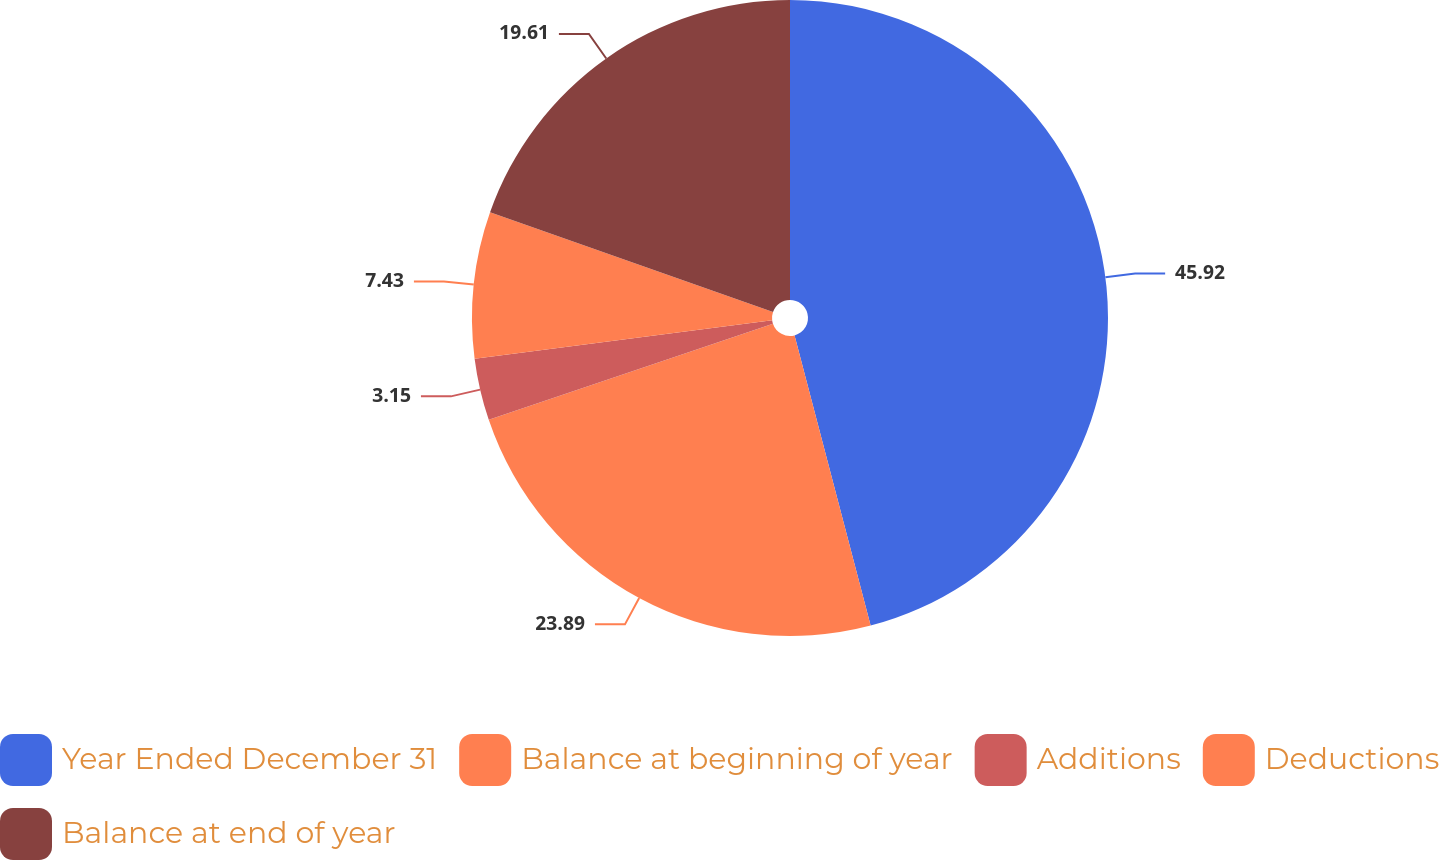Convert chart to OTSL. <chart><loc_0><loc_0><loc_500><loc_500><pie_chart><fcel>Year Ended December 31<fcel>Balance at beginning of year<fcel>Additions<fcel>Deductions<fcel>Balance at end of year<nl><fcel>45.92%<fcel>23.89%<fcel>3.15%<fcel>7.43%<fcel>19.61%<nl></chart> 